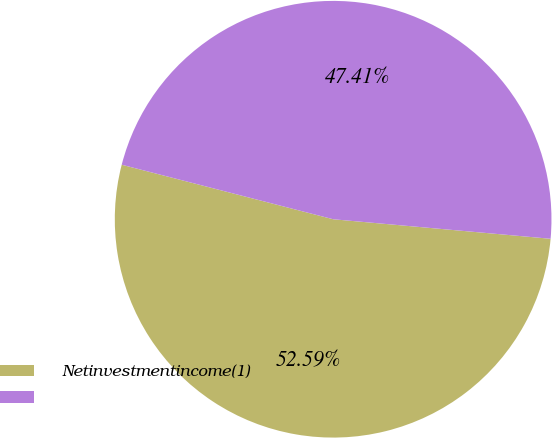Convert chart. <chart><loc_0><loc_0><loc_500><loc_500><pie_chart><fcel>Netinvestmentincome(1)<fcel>Unnamed: 1<nl><fcel>52.59%<fcel>47.41%<nl></chart> 